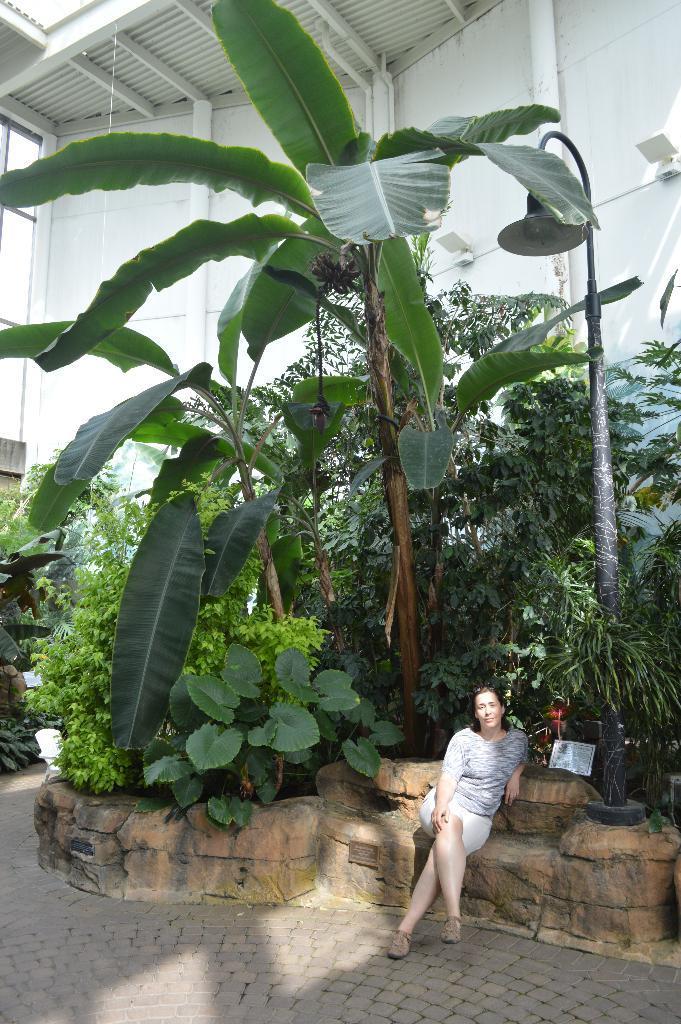Describe this image in one or two sentences. This picture is taken from outside of the city. In this image, on the right side, we can see a woman sitting on the stones. In the background, we can see some trees, plants, building, pipe. At the top, we can see a roof which is in white color, at the bottom, we can see a land. 